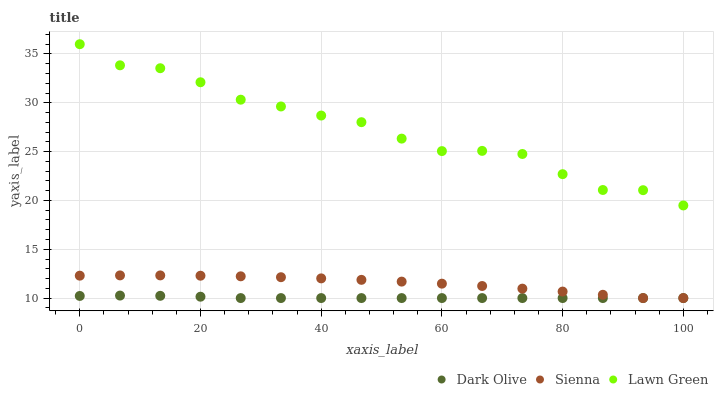Does Dark Olive have the minimum area under the curve?
Answer yes or no. Yes. Does Lawn Green have the maximum area under the curve?
Answer yes or no. Yes. Does Lawn Green have the minimum area under the curve?
Answer yes or no. No. Does Dark Olive have the maximum area under the curve?
Answer yes or no. No. Is Dark Olive the smoothest?
Answer yes or no. Yes. Is Lawn Green the roughest?
Answer yes or no. Yes. Is Lawn Green the smoothest?
Answer yes or no. No. Is Dark Olive the roughest?
Answer yes or no. No. Does Sienna have the lowest value?
Answer yes or no. Yes. Does Lawn Green have the lowest value?
Answer yes or no. No. Does Lawn Green have the highest value?
Answer yes or no. Yes. Does Dark Olive have the highest value?
Answer yes or no. No. Is Dark Olive less than Lawn Green?
Answer yes or no. Yes. Is Lawn Green greater than Dark Olive?
Answer yes or no. Yes. Does Sienna intersect Dark Olive?
Answer yes or no. Yes. Is Sienna less than Dark Olive?
Answer yes or no. No. Is Sienna greater than Dark Olive?
Answer yes or no. No. Does Dark Olive intersect Lawn Green?
Answer yes or no. No. 